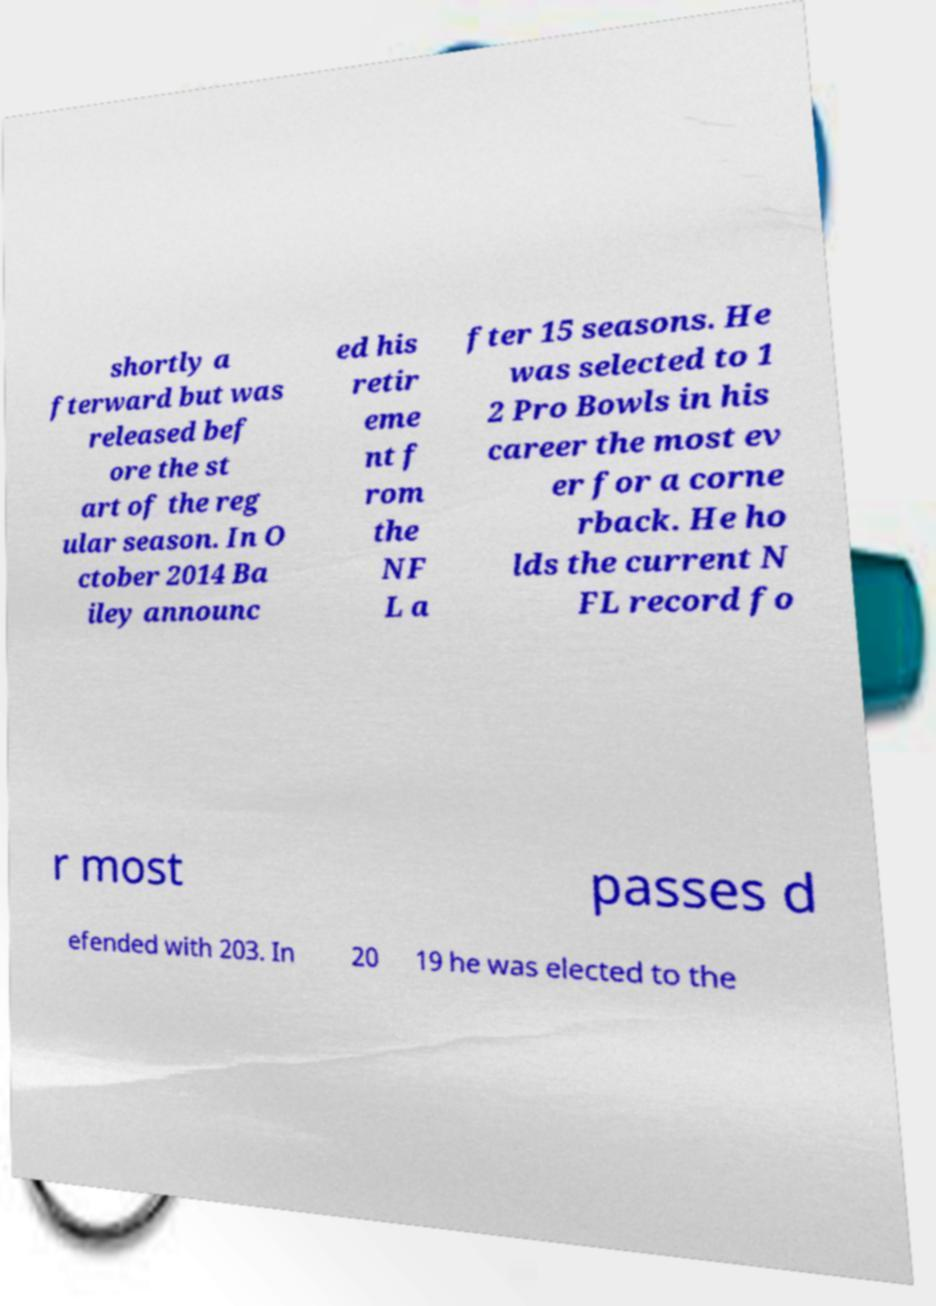Please identify and transcribe the text found in this image. shortly a fterward but was released bef ore the st art of the reg ular season. In O ctober 2014 Ba iley announc ed his retir eme nt f rom the NF L a fter 15 seasons. He was selected to 1 2 Pro Bowls in his career the most ev er for a corne rback. He ho lds the current N FL record fo r most passes d efended with 203. In 20 19 he was elected to the 